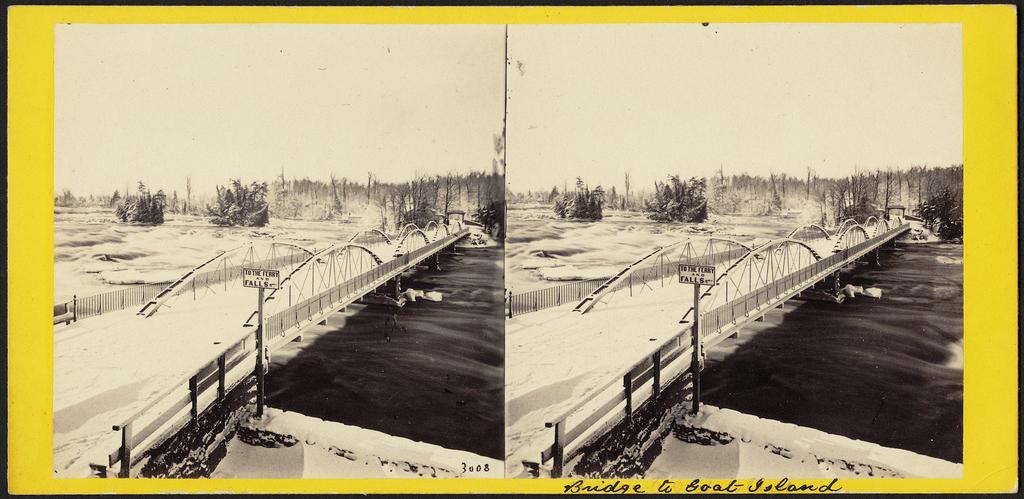What type of artwork is the image? The image is a collage. What structure can be seen in the image? There is a bridge in the image. What natural element is present in the image? There is water in the image. What type of vegetation is in the image? There are trees in the image. What part of the sky is visible in the image? The sky is visible in the image. What is attached to the pole on the right side of the bridge? There is a board on the right side of the bridge. What can be found written on the image? There is text written on the image. What type of apple is being used in the industry depicted in the image? There is no apple or industry present in the image; it is a collage featuring a bridge, water, trees, and a sky. 